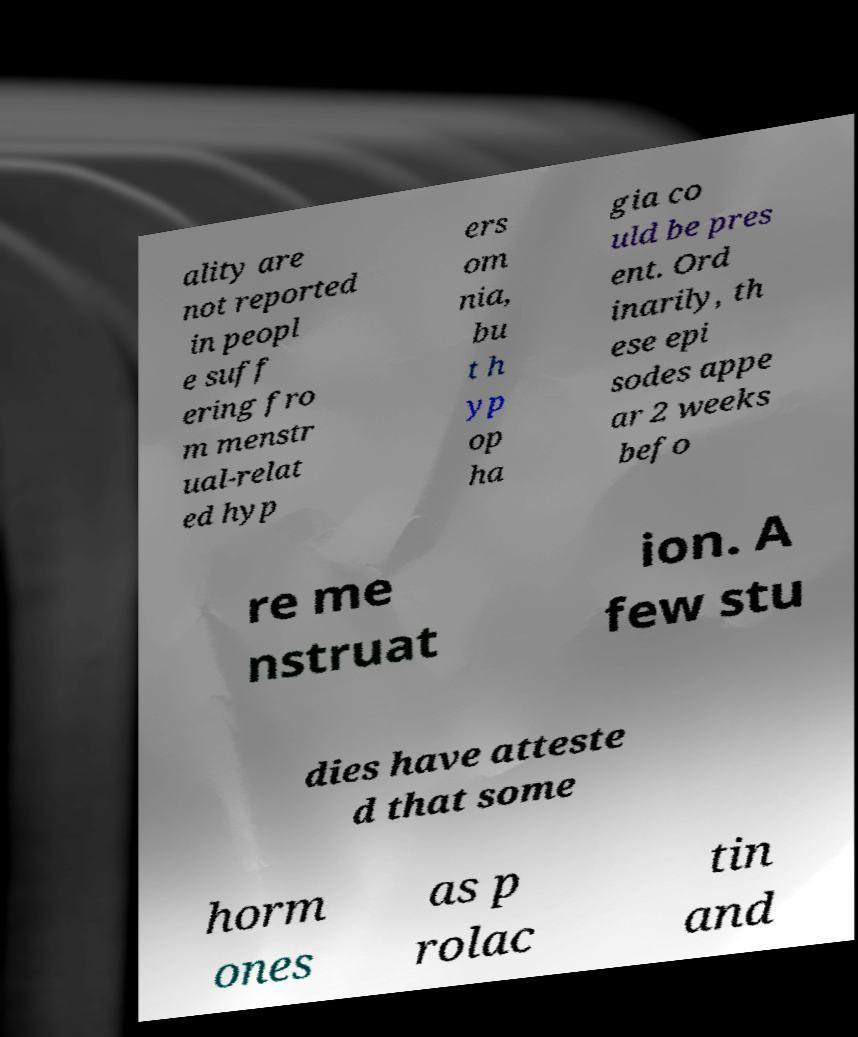I need the written content from this picture converted into text. Can you do that? ality are not reported in peopl e suff ering fro m menstr ual-relat ed hyp ers om nia, bu t h yp op ha gia co uld be pres ent. Ord inarily, th ese epi sodes appe ar 2 weeks befo re me nstruat ion. A few stu dies have atteste d that some horm ones as p rolac tin and 